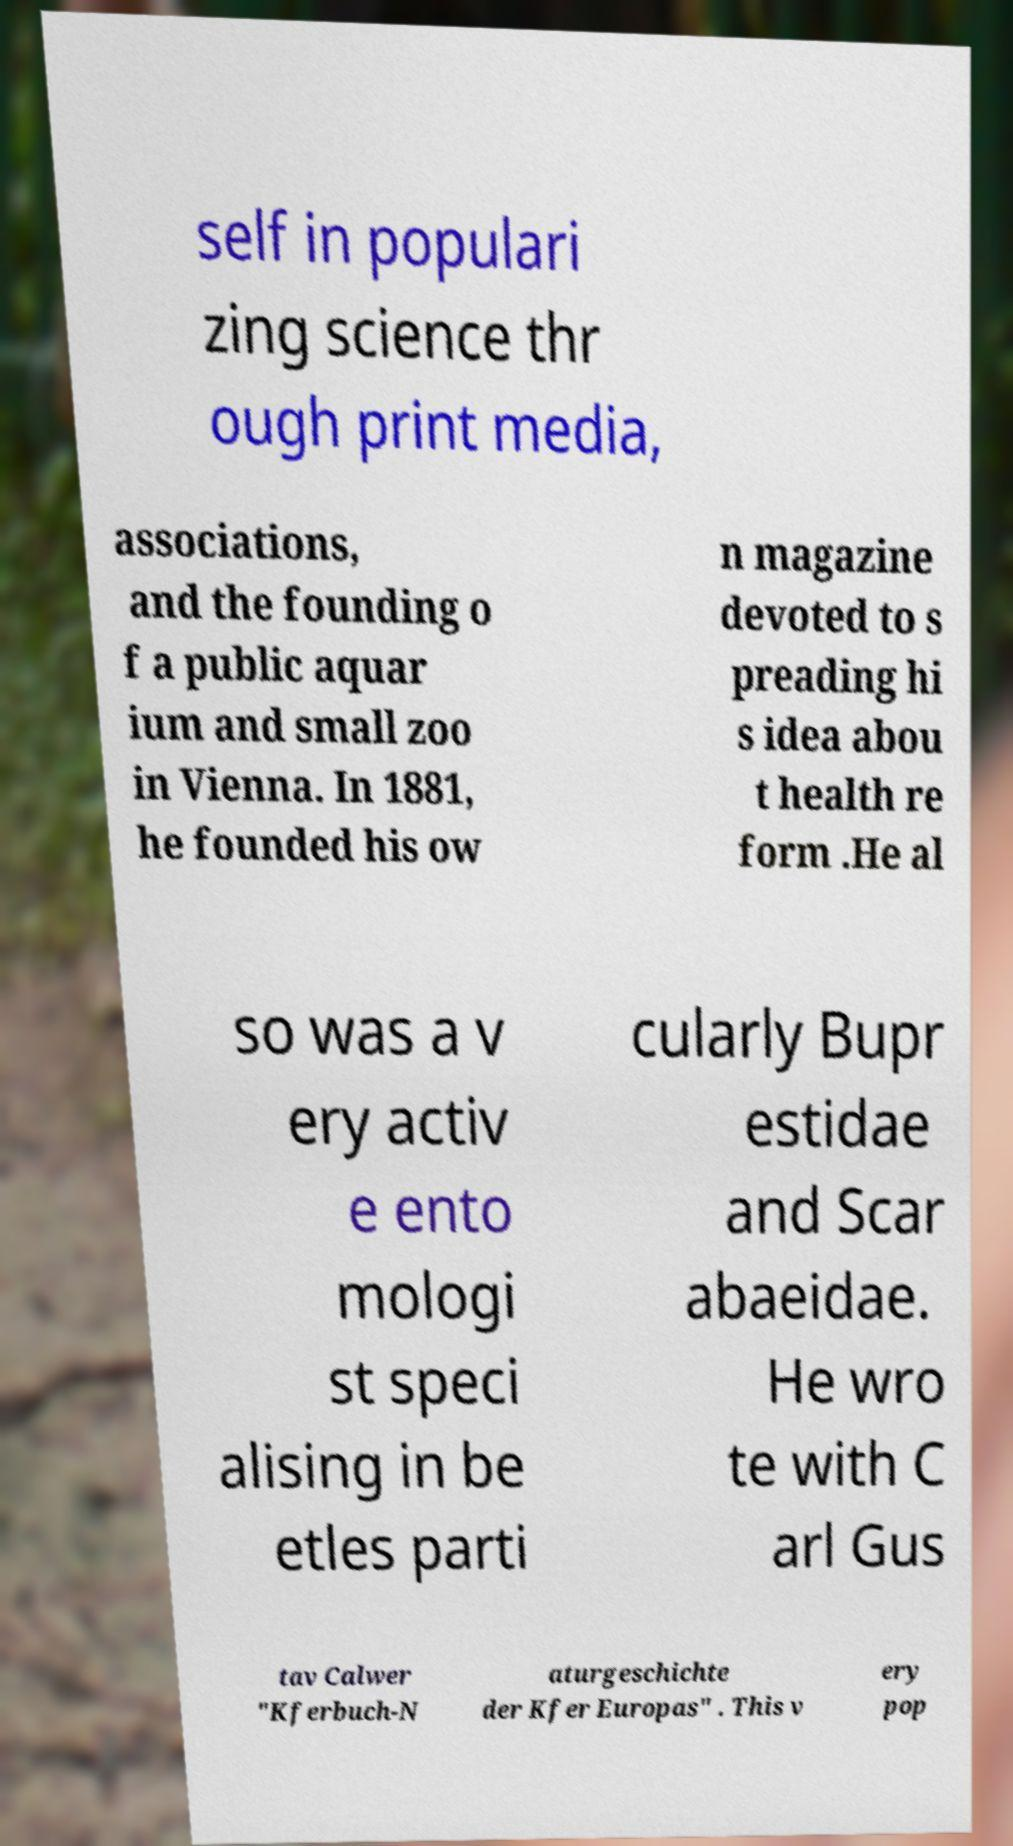What messages or text are displayed in this image? I need them in a readable, typed format. self in populari zing science thr ough print media, associations, and the founding o f a public aquar ium and small zoo in Vienna. In 1881, he founded his ow n magazine devoted to s preading hi s idea abou t health re form .He al so was a v ery activ e ento mologi st speci alising in be etles parti cularly Bupr estidae and Scar abaeidae. He wro te with C arl Gus tav Calwer "Kferbuch-N aturgeschichte der Kfer Europas" . This v ery pop 